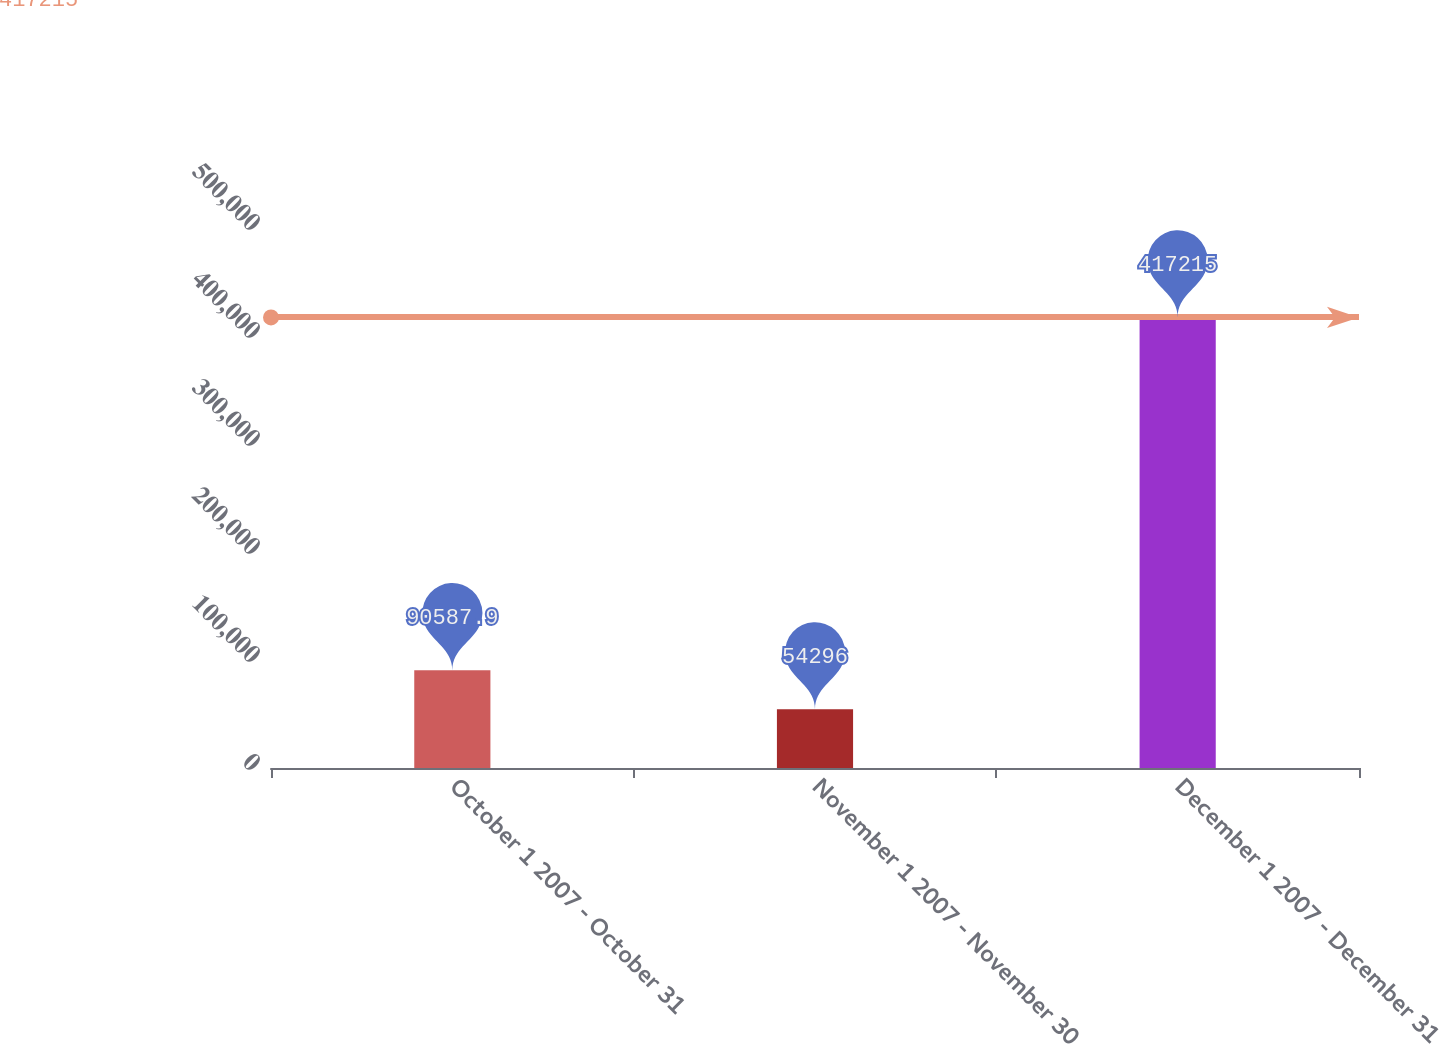Convert chart. <chart><loc_0><loc_0><loc_500><loc_500><bar_chart><fcel>October 1 2007 - October 31<fcel>November 1 2007 - November 30<fcel>December 1 2007 - December 31<nl><fcel>90587.9<fcel>54296<fcel>417215<nl></chart> 